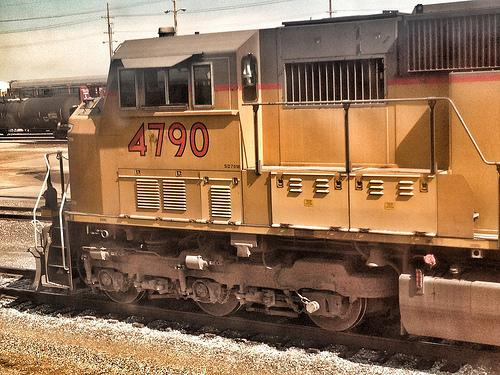Question: when was the photo taken?
Choices:
A. Yesterday.
B. Last night.
C. Midnight.
D. Daytime.
Answer with the letter. Answer: D Question: what numbers do you see?
Choices:
A. 9100.
B. 1962.
C. 2006.
D. 4790.
Answer with the letter. Answer: D Question: how window panes do you see above the numbers?
Choices:
A. 4.
B. 3.
C. 2.
D. 7.
Answer with the letter. Answer: A Question: what color is the train?
Choices:
A. Blue.
B. Red.
C. Green.
D. Orange.
Answer with the letter. Answer: D 